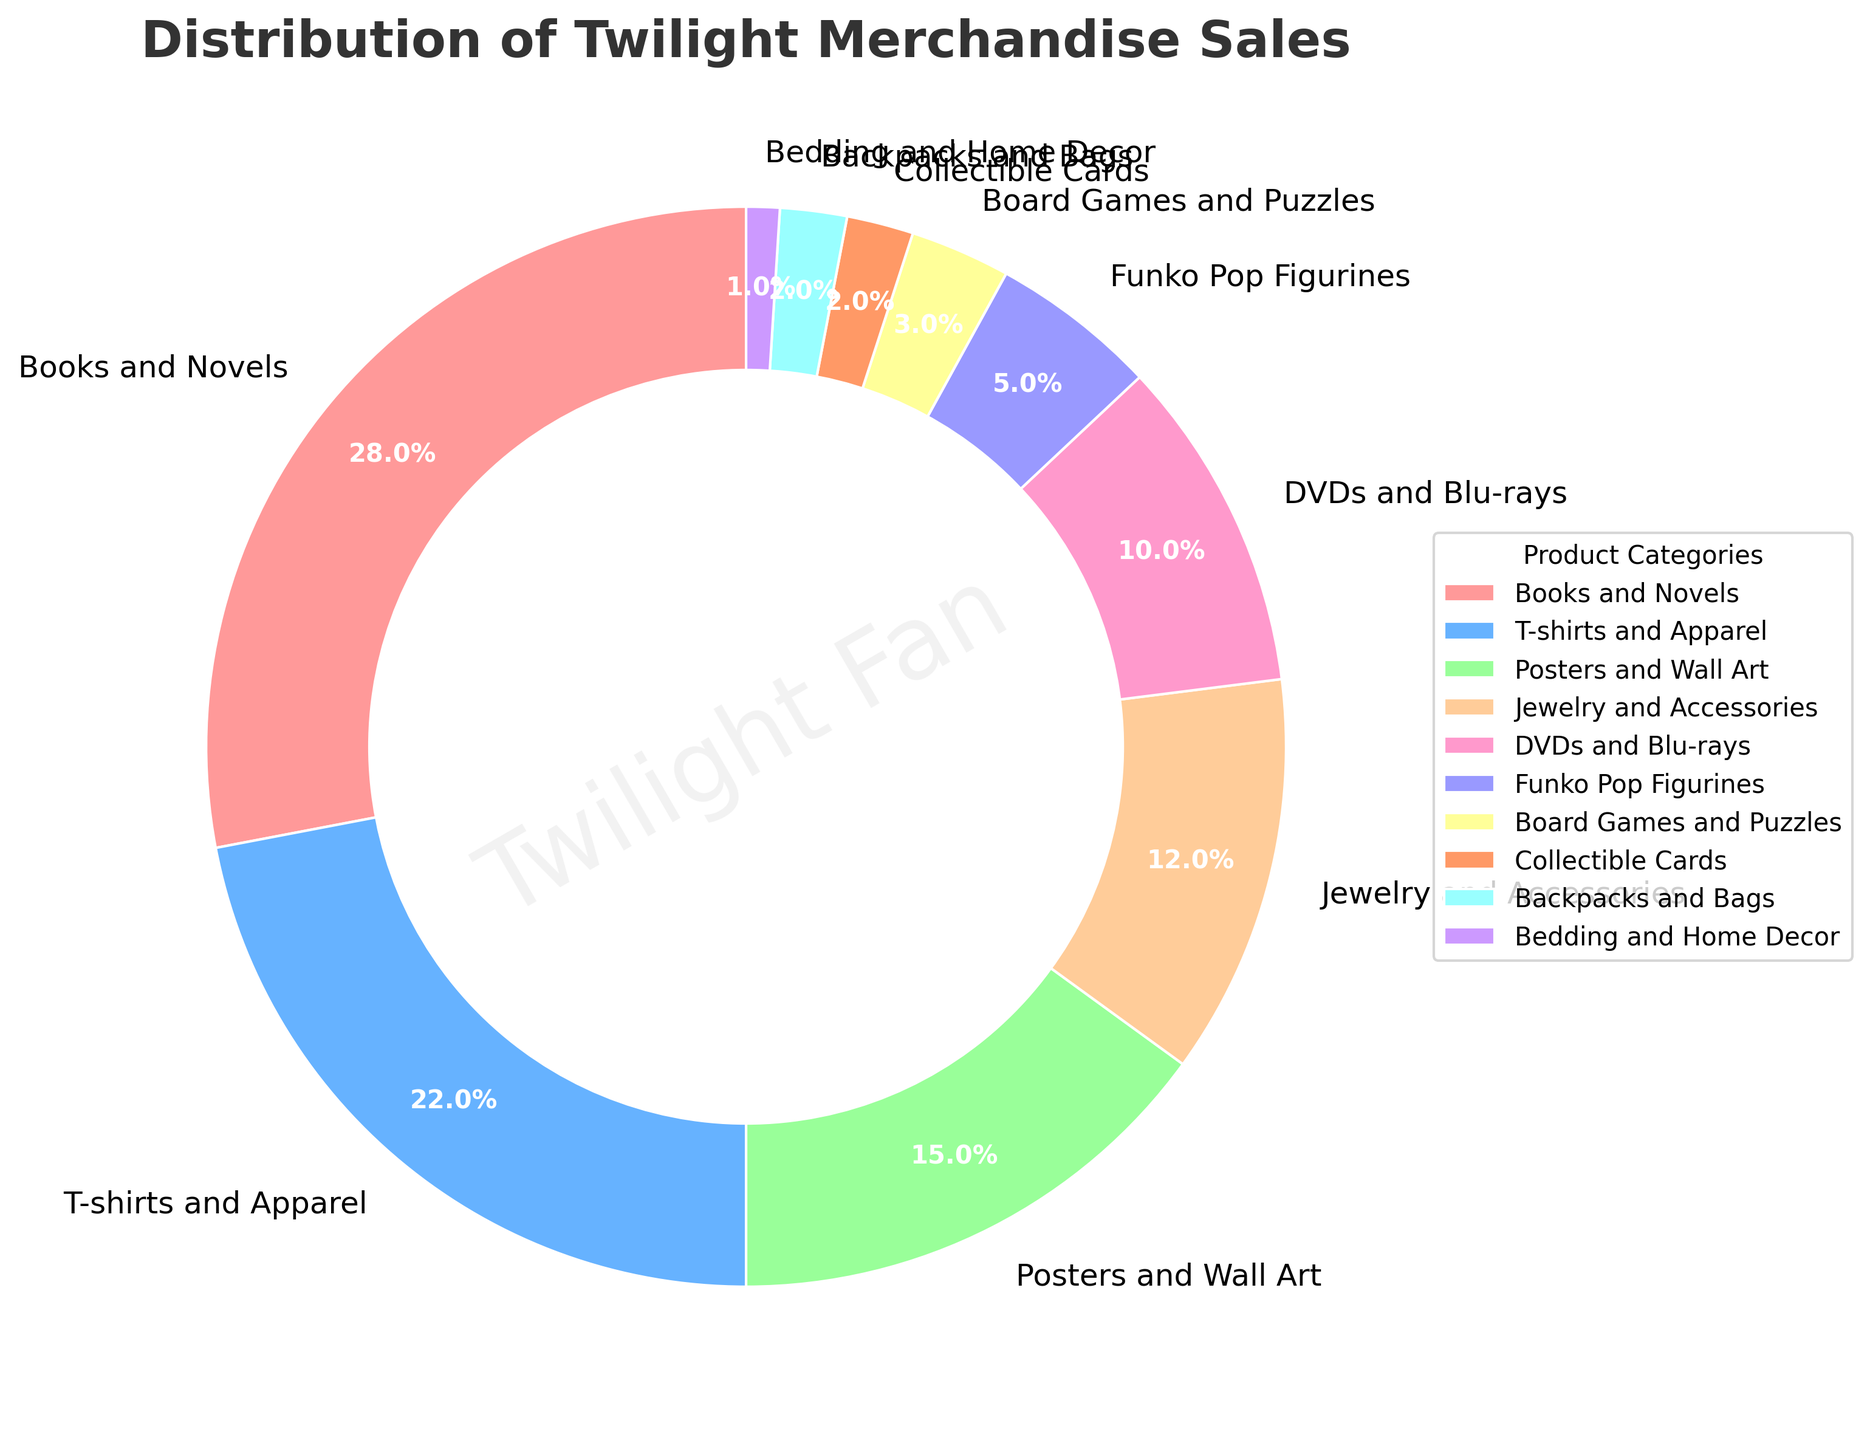What's the largest product category in the Twilight merchandise sales distribution? First identify the product category with the largest percentage. "Books and Novels" has the highest percentage at 28%.
Answer: Books and Novels Which category has a higher sales percentage: T-shirts and Apparel or Jewelry and Accessories? Compare the percentages of "T-shirts and Apparel" (22%) and "Jewelry and Accessories" (12%). "T-shirts and Apparel" has a higher percentage.
Answer: T-shirts and Apparel What's the total percentage of the top three categories combined? Add the percentages of the top three categories: "Books and Novels" (28%), "T-shirts and Apparel" (22%), and "Posters and Wall Art" (15%). 28 + 22 + 15 = 65%.
Answer: 65% How much greater is the percentage of DVDs and Blu-rays compared to Board Games and Puzzles? Subtract the percentage of "Board Games and Puzzles" (3%) from "DVDs and Blu-rays" (10%). 10 - 3 = 7%.
Answer: 7% Are Funko Pop Figurines more or less popular than Jewelry and Accessories? Compare the percentages of "Funko Pop Figurines" (5%) and "Jewelry and Accessories" (12%); "Funko Pop Figurines" are less popular.
Answer: Less Which product category has the smallest sales percentage? Identify the product category with the smallest percentage, which is "Bedding and Home Decor" at 1%.
Answer: Bedding and Home Decor What is the combined percentage of the four least popular categories? Add the percentages of the four categories with the lowest percentages: "Board Games and Puzzles" (3%), "Collectible Cards" (2%), "Backpacks and Bags" (2%), "Bedding and Home Decor" (1%). 3 + 2 + 2 + 1 = 8%.
Answer: 8% If you combine the sales percentages of Posters and Wall Art and DVDs and Blu-rays, how does it compare to the percentage of Books and Novels? Add the percentages of "Posters and Wall Art" (15%) and "DVDs and Blu-rays" (10%). Compare to "Books and Novels" (28%). 15 + 10 = 25%, which is less than 28%.
Answer: Less What is the sales percentage difference between the second highest and second lowest categories? Identify the second highest ("T-shirts and Apparel" - 22%) and the second lowest ("Collectible Cards" and "Backpacks and Bags" - 2%). Subtract: 22 - 2 = 20%.
Answer: 20% Do T-shirts and Apparel account for more than 20% of the sales? Look at the percentage for "T-shirts and Apparel", which is 22%, greater than 20%.
Answer: Yes 